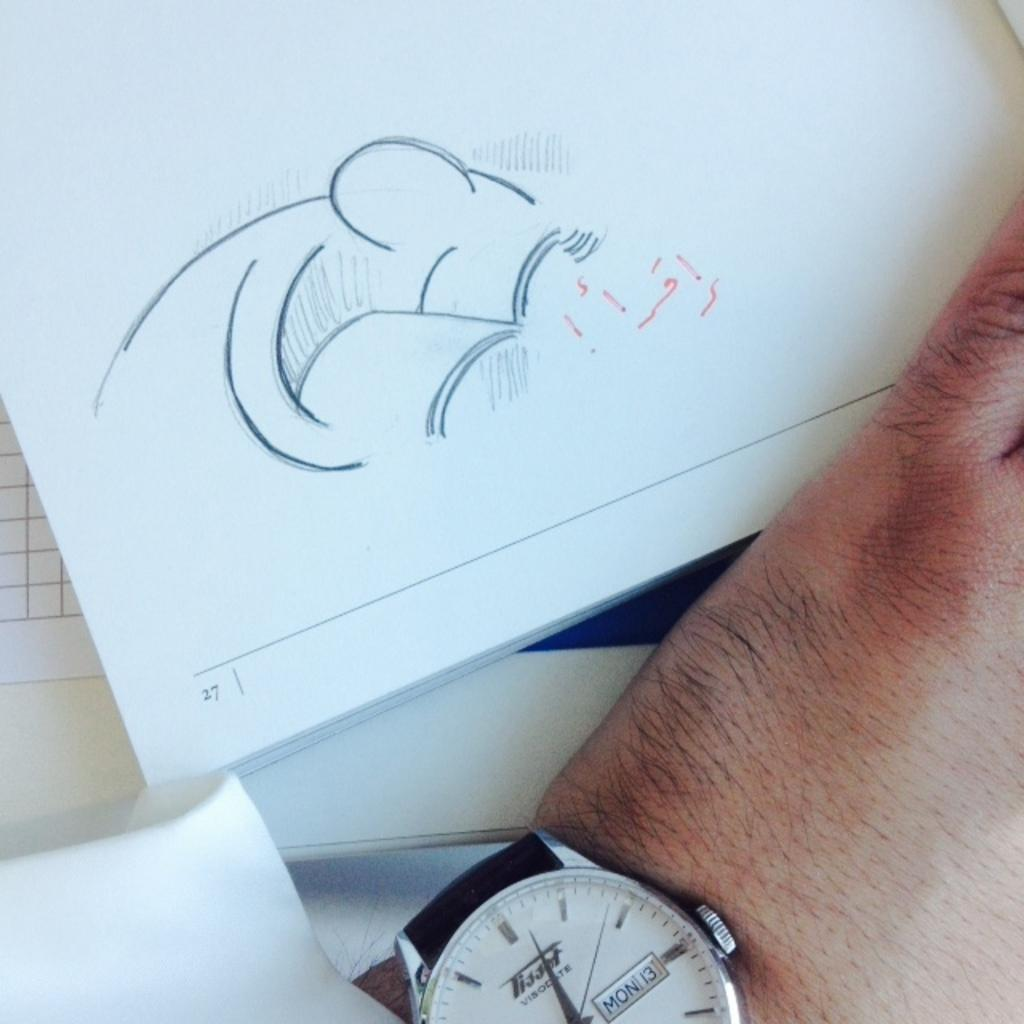<image>
Give a short and clear explanation of the subsequent image. A man looks at page 27 on Monday the 13th. 